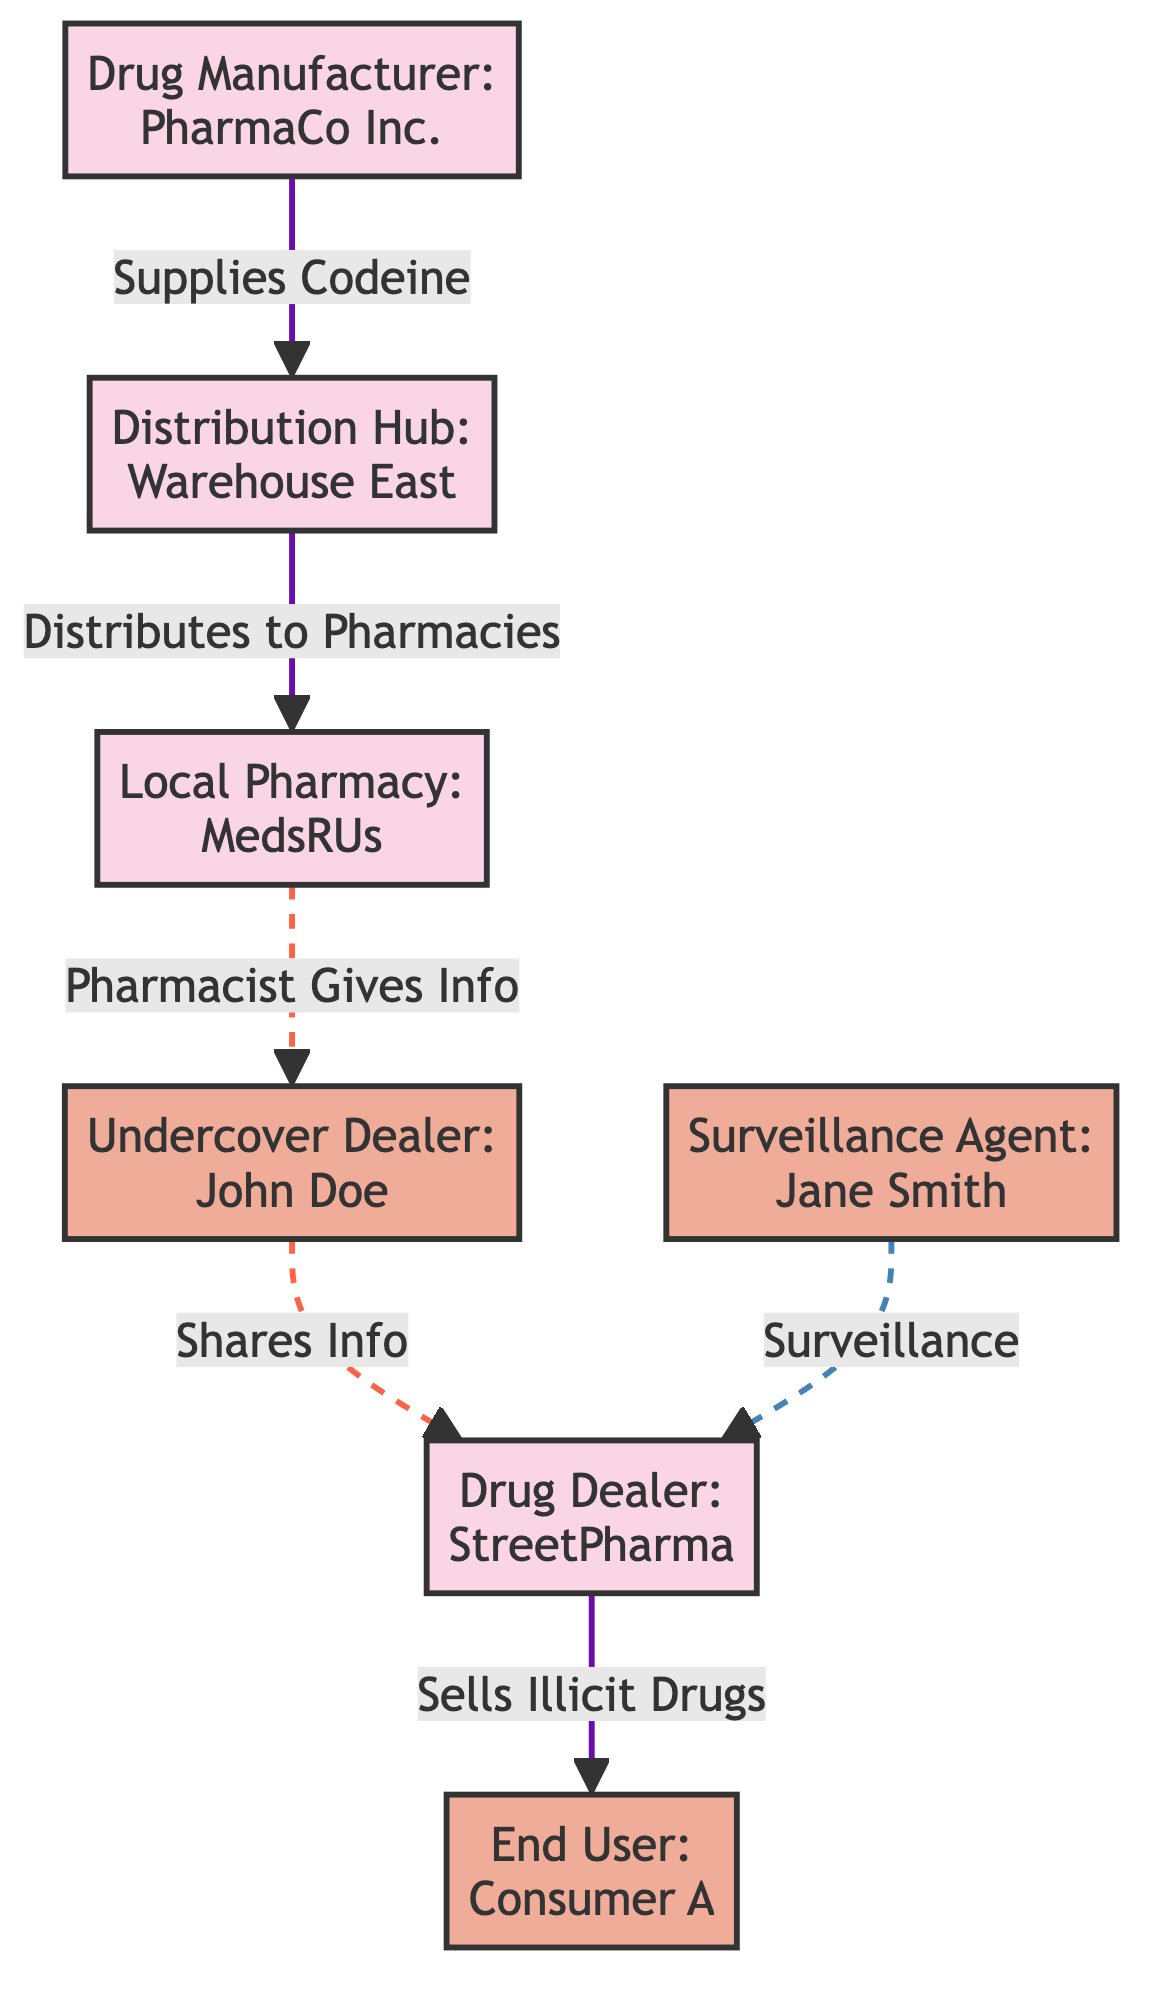What is the role of PharmaCo Inc.? PharmaCo Inc. is identified as the drug manufacturer in the diagram. It supplies codeine to the distribution hub, which indicates its primary function in the network flow.
Answer: Drug Manufacturer Who receives distribution from Warehouse East? Warehouse East is a distribution hub that distributes to MedsRUs, the local pharmacy. Thus, MedsRUs receives the supplies from Warehouse East.
Answer: MedsRUs How many personnel are involved in the surveillance of StreetPharma? The diagram indicates one surveillance agent, Jane Smith, monitoring the activities of StreetPharma, which is the drug dealer.
Answer: One Which entity directly shares information with the undercover dealer? The pharmacist from MedsRUs shares information directly with the undercover dealer, John Doe, as indicated by the dashed arrow connecting these nodes.
Answer: MedsRUs What is the final destination of illicit drugs sold by StreetPharma? The end user listed in the diagram as Consumer A is the final destination of illicit drugs that are sold by StreetPharma.
Answer: Consumer A Who is responsible for supplying codeine to the distribution hub? PharmaCo Inc. is identified as the supplier of codeine to the distribution hub, Warehouse East, shown by the directed edge in the diagram.
Answer: PharmaCo Inc What type of relationship exists between John Doe and StreetPharma? The relationship between John Doe (the undercover dealer) and StreetPharma is represented by a dashed line indicating that John shares information with StreetPharma.
Answer: Shares Info Which node represents the individual involved in surveillance? The node labeled Jane Smith represents the surveillance agent in the diagram, overseeing the actions of the drug dealer StreetPharma.
Answer: Jane Smith How do illicit drugs reach the end user? The illicit drugs flow from the drug dealer, StreetPharma, directly to the end user, Consumer A, as indicated by the directed arrow from one node to the other.
Answer: StreetPharma to Consumer A 